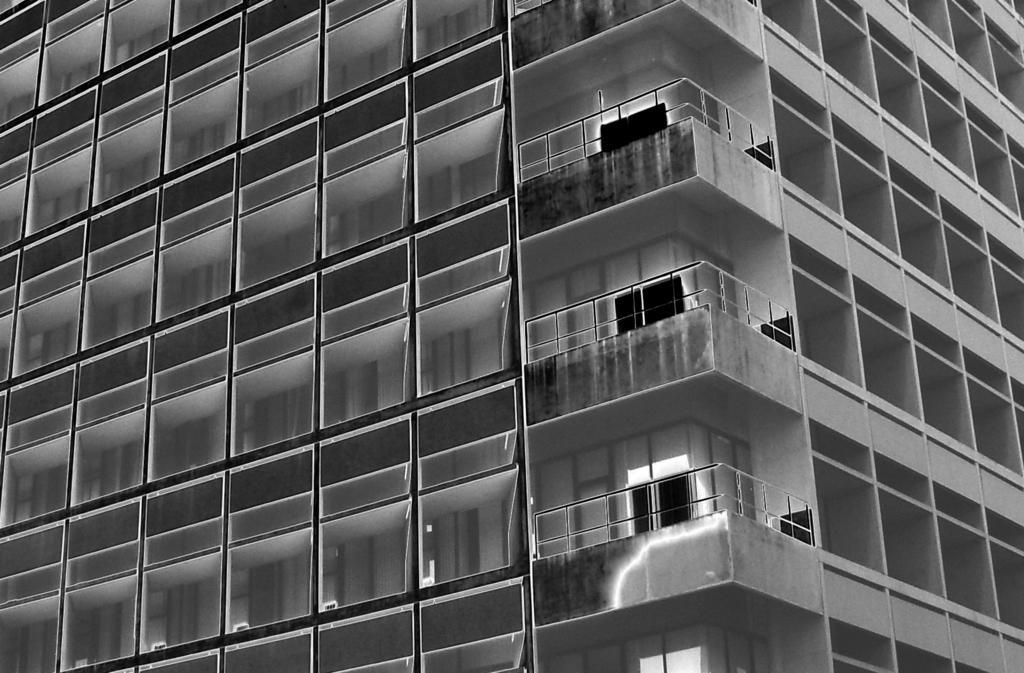How would you summarize this image in a sentence or two? In the picture we can see a part of the building with many windows and glasses to it and railing to the corner of every floor. 